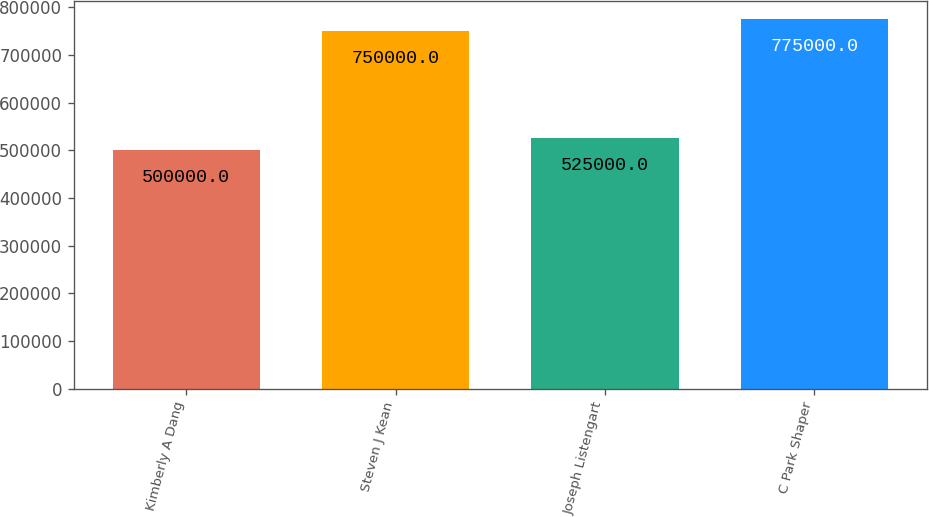Convert chart. <chart><loc_0><loc_0><loc_500><loc_500><bar_chart><fcel>Kimberly A Dang<fcel>Steven J Kean<fcel>Joseph Listengart<fcel>C Park Shaper<nl><fcel>500000<fcel>750000<fcel>525000<fcel>775000<nl></chart> 